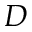<formula> <loc_0><loc_0><loc_500><loc_500>D</formula> 